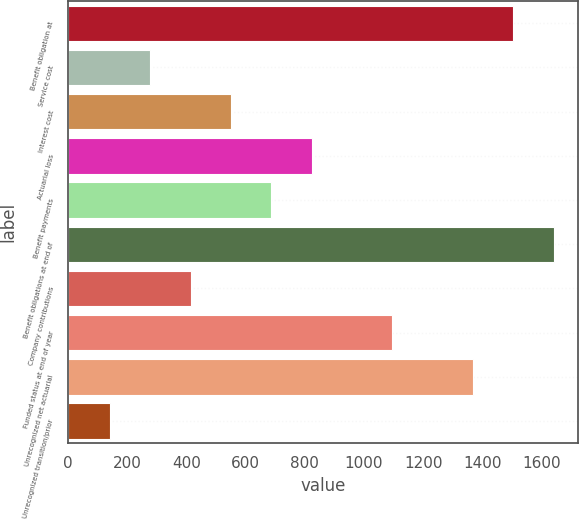Convert chart to OTSL. <chart><loc_0><loc_0><loc_500><loc_500><bar_chart><fcel>Benefit obligation at<fcel>Service cost<fcel>Interest cost<fcel>Actuarial loss<fcel>Benefit payments<fcel>Benefit obligations at end of<fcel>Company contributions<fcel>Funded status at end of year<fcel>Unrecognized net actuarial<fcel>Unrecognized transition/prior<nl><fcel>1504.51<fcel>278.25<fcel>550.75<fcel>823.25<fcel>687<fcel>1640.76<fcel>414.5<fcel>1095.76<fcel>1368.26<fcel>142<nl></chart> 